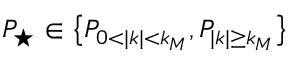<formula> <loc_0><loc_0><loc_500><loc_500>P _ { ^ { * } } \in \left \{ P _ { 0 < | k | < k _ { M } } , P _ { | k | \geq k _ { M } } \right \}</formula> 